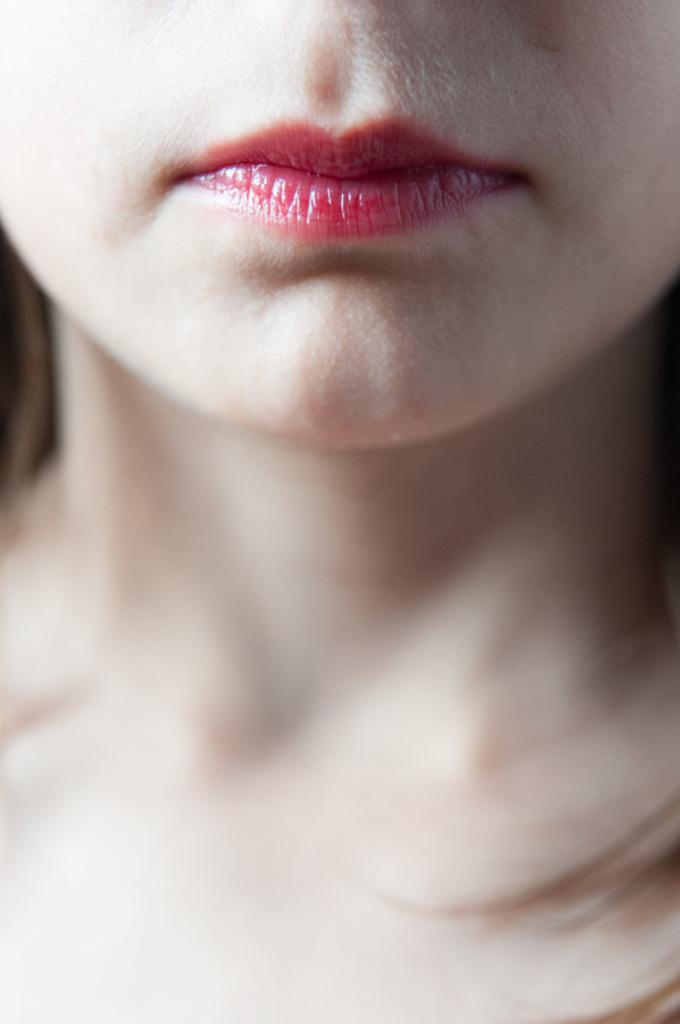Who is the main subject in the image? There is a woman in the image. What part of the woman's face is visible in the image? The woman's lips are visible in the image. What can be seen about the woman's appearance in the image? The woman's hair is visible in the image. What type of butter is the woman holding in the image? There is no butter present in the image; it only features the woman and her visible lips and hair. 